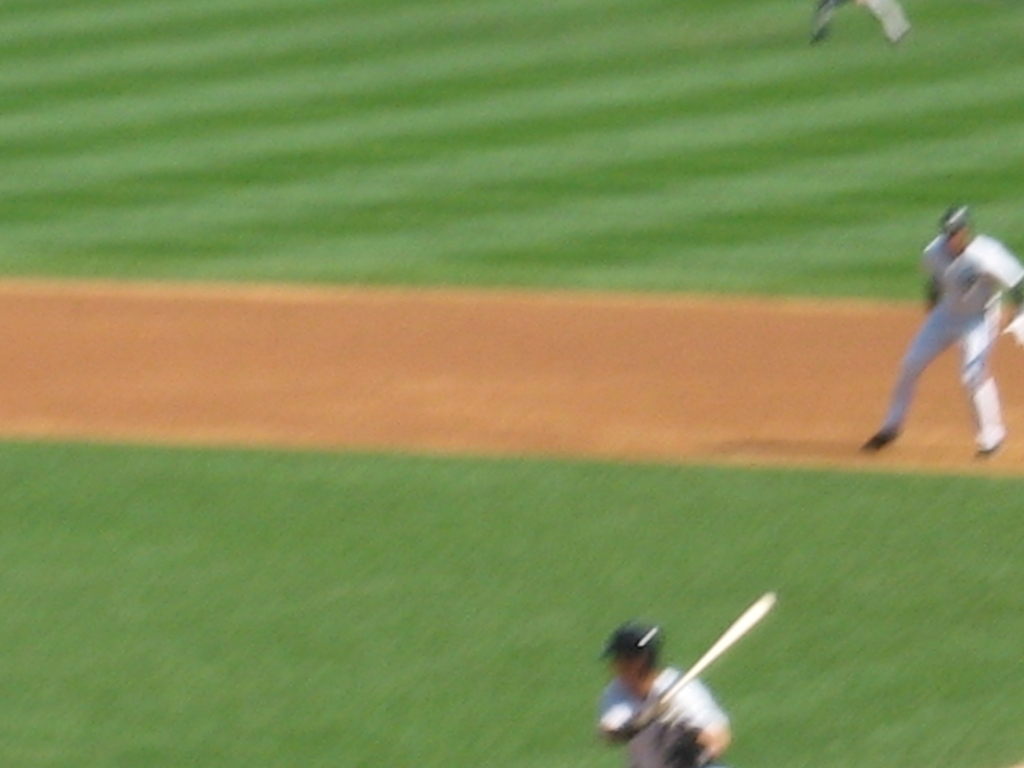What would make this image more visually appealing? Improving the image's sharpness by reducing blur would make it more visually appealing, along with possibly enhancing the contrast and saturation to make the colors pop. Also, framing the shot to capture the action of the pitch or the swing could add drama to the scene. Is there an emotional or thematic aspect that could be accentuated? Certainly, emphasizing the anticipation or climax of the play could invoke excitement or tension. Capturing the expressions and body language of the players right before a critical moment can enhance the emotional impact, creating a connection with the viewer and conveying the intense atmosphere of the game. 